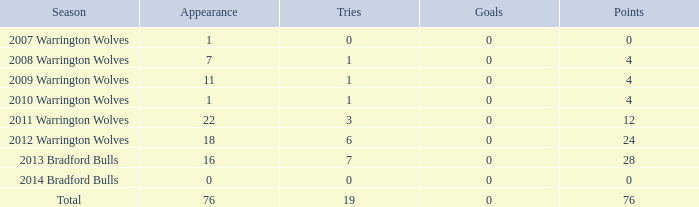What is the lowest appearance when goals is more than 0? None. 